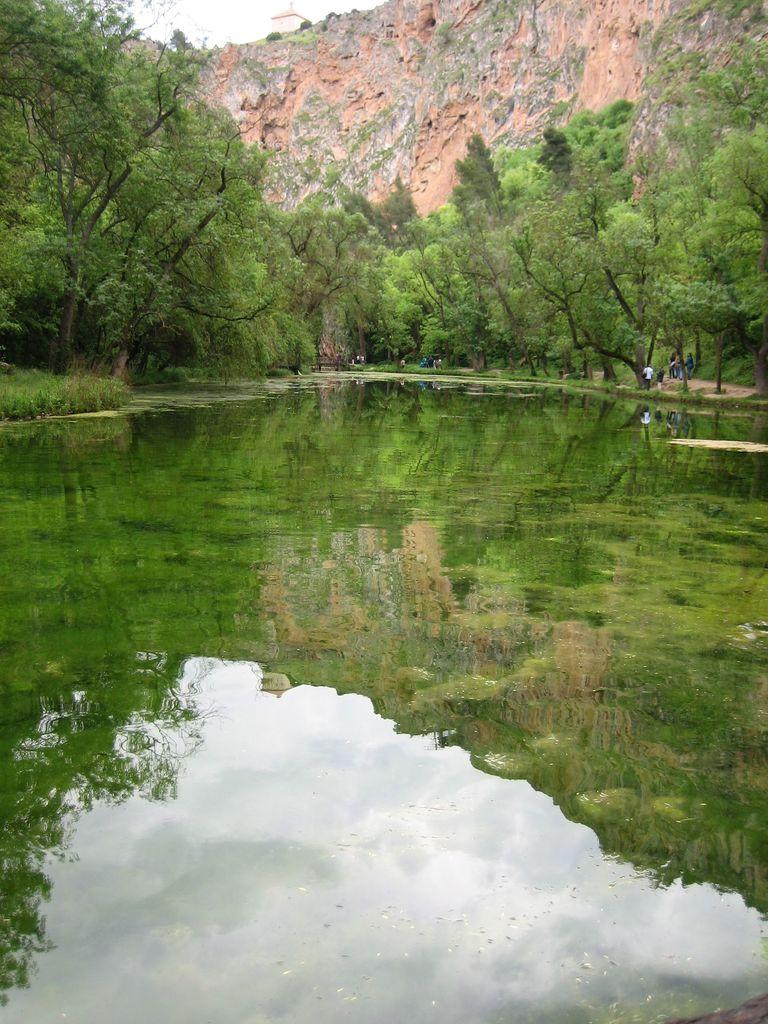What is the primary element visible in the image? There is water in the image. What type of vegetation can be seen in the front of the image? There are many trees in the front of the image. What type of geographical feature is visible in the background of the image? There is a mountain in the background of the image. What is visible at the top of the image? The sky is visible at the top of the image. What type of paint is being used to create the riddle in the garden? There is no paint, riddle, or garden present in the image; it features water, trees, a mountain, and the sky. 